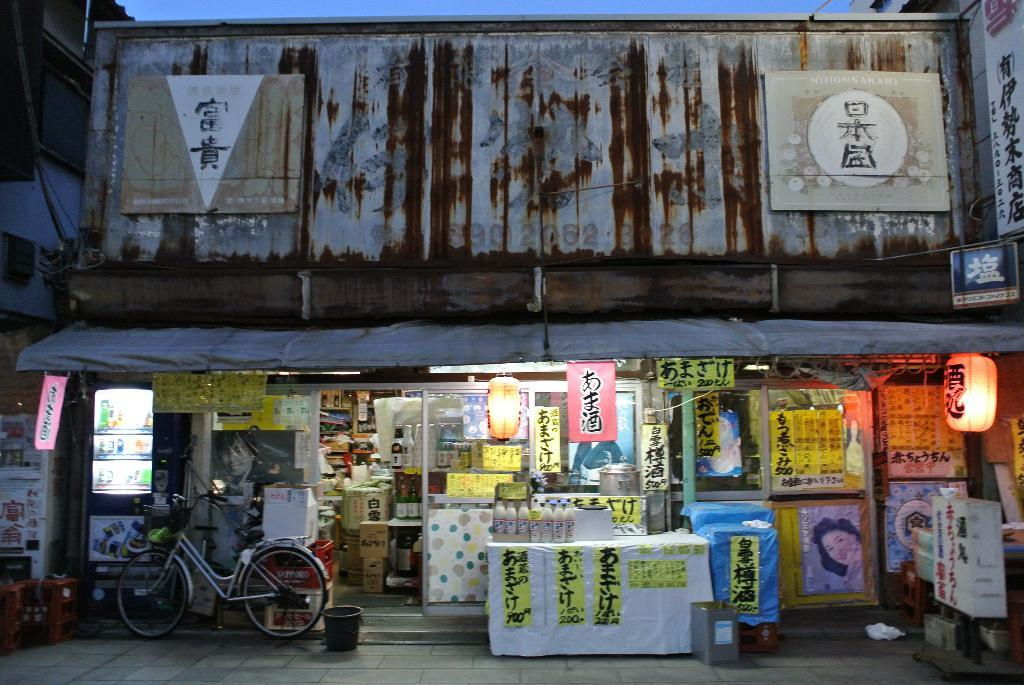<image>
Render a clear and concise summary of the photo. A Chinese store has some liquid for sale for 900 Yen 